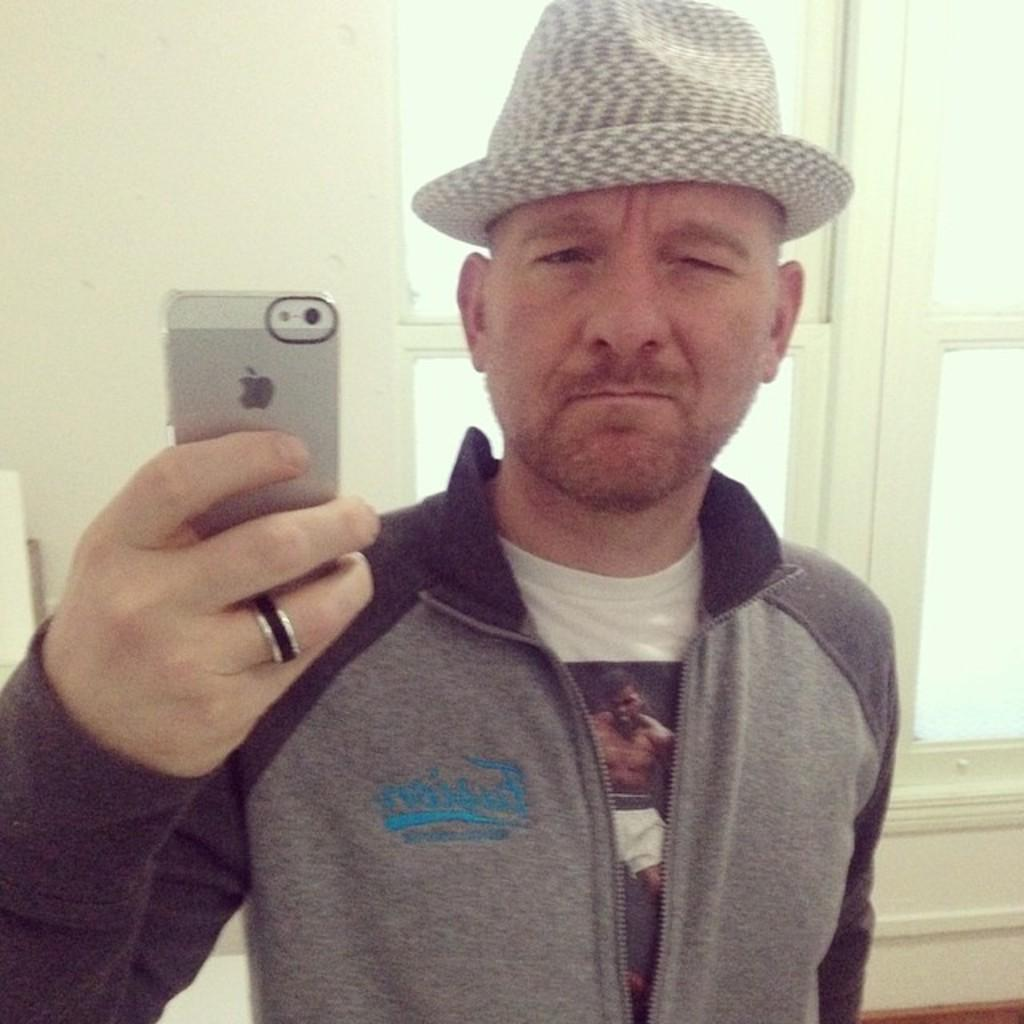What is the main subject in the foreground of the image? There is a person standing in the foreground of the image. What is the person wearing? The person is wearing a hat. What is the person holding in the image? The person is holding a mobile. What can be seen in the background of the image? There is a window and a wall in the background of the image. How many chairs are visible in the image? There are no chairs visible in the image. What type of humor is being displayed in the image? There is no humor present in the image; it is a straightforward depiction of a person standing with a hat and holding a mobile. 